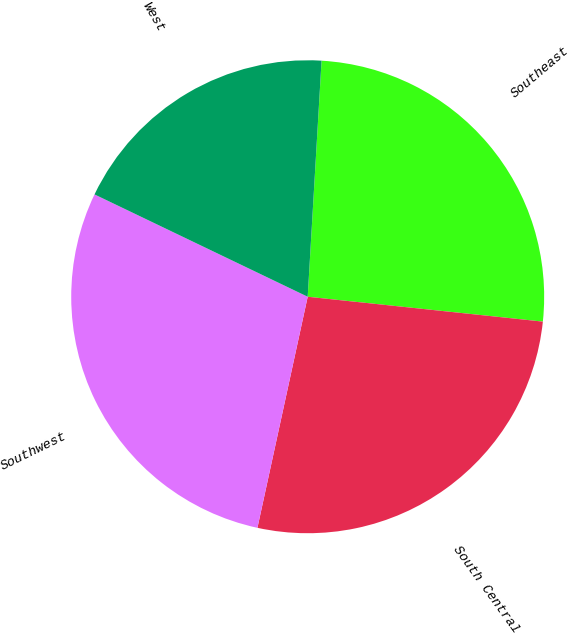<chart> <loc_0><loc_0><loc_500><loc_500><pie_chart><fcel>Southeast<fcel>South Central<fcel>Southwest<fcel>West<nl><fcel>25.74%<fcel>26.73%<fcel>28.71%<fcel>18.81%<nl></chart> 